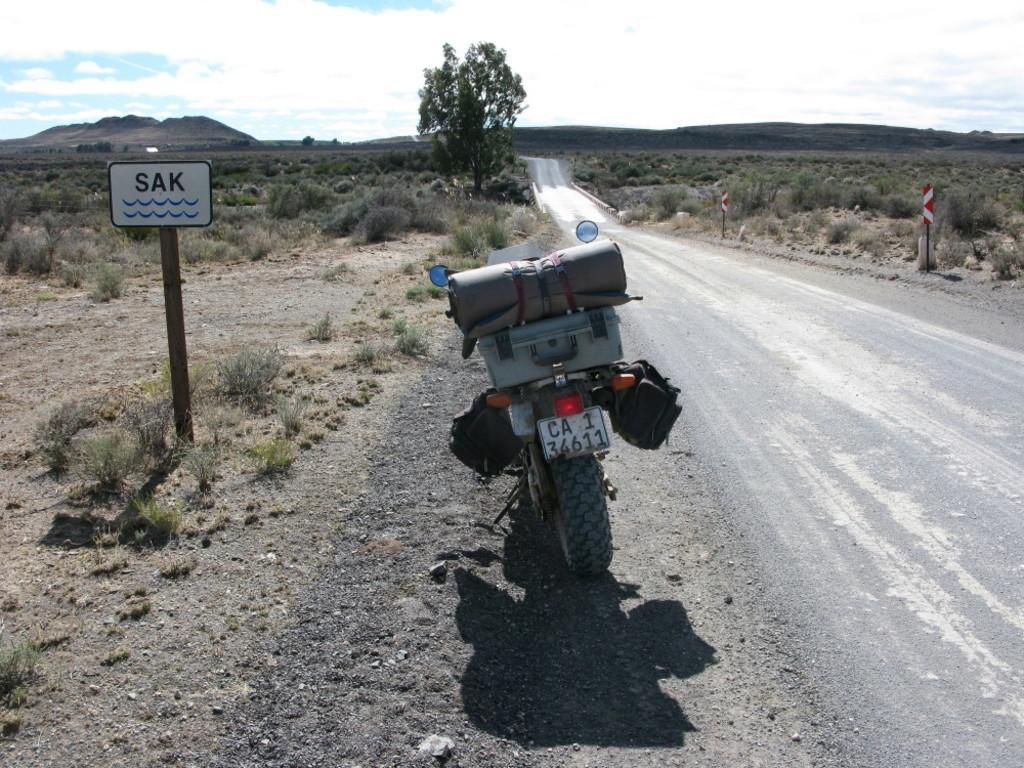In one or two sentences, can you explain what this image depicts? In the picture we can see a road beside it, we can see a motor bike with luggage on it and beside it, we can see a pole with board and beside it, we can see some plants on the surface and on the opposite side, we can see a surface with full of plants and in the background we can see plants, trees and behind it we can see hills and sky with clouds. 